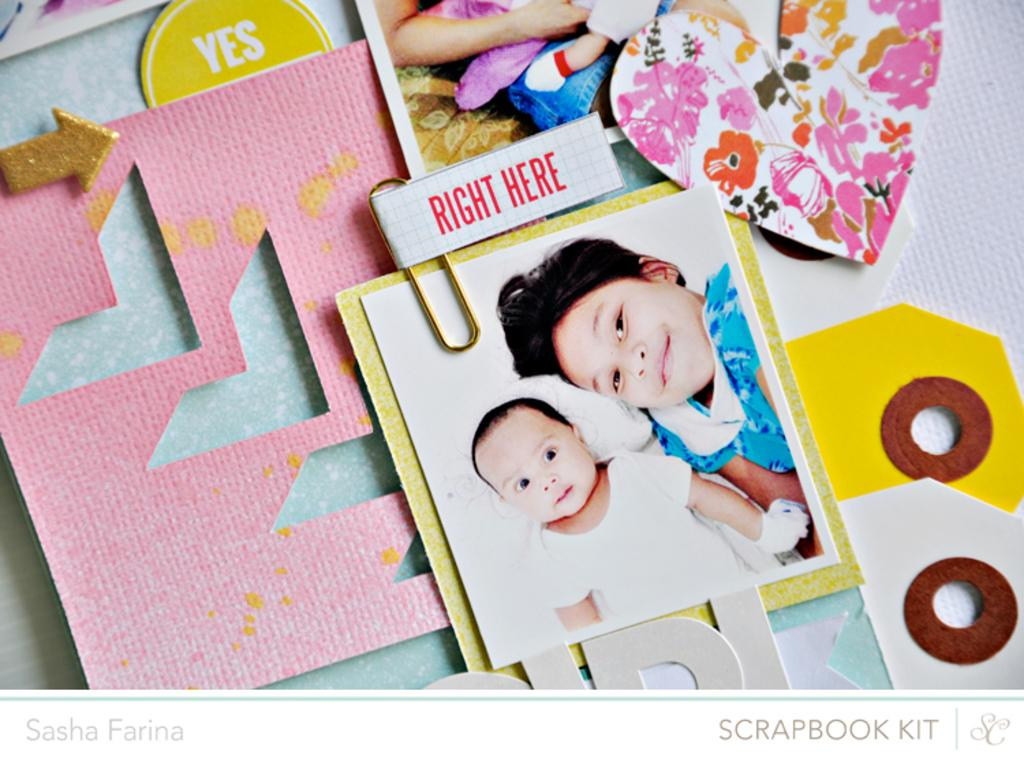What type of items can be seen in the image? There are photos and text in the image. What can be inferred about the image based on the presence of photos and text? The image appears to be a greeting card. Where is text located in the image? There is text in the bottom left corner and the bottom right corner of the image. What type of jelly can be seen in the image? There is no jelly present in the image. How does the text in the image relate to the digestion process? The image does not depict or mention anything related to digestion. 